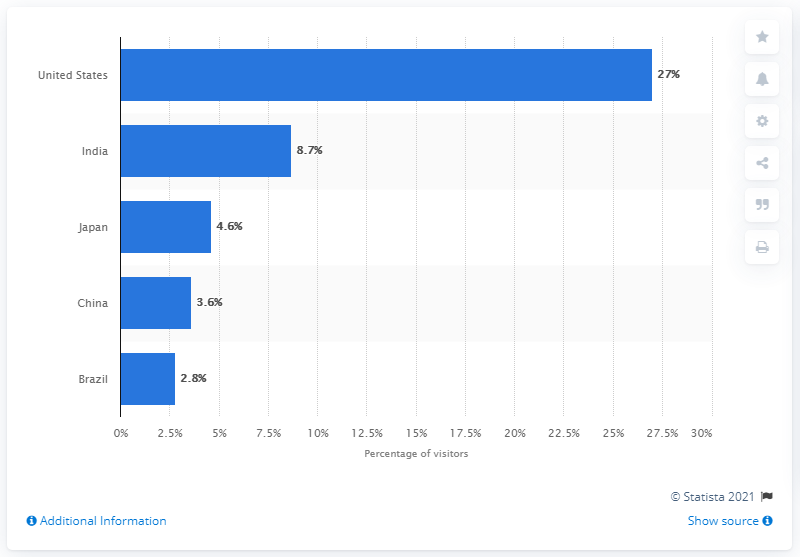Outline some significant characteristics in this image. Google.com found 2.8 percent of its visitors from Brazil. 